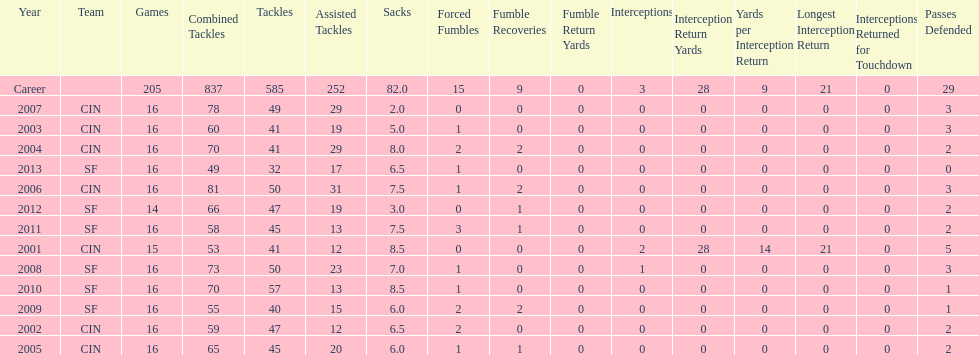How many seasons had combined tackles of 70 or more? 5. 